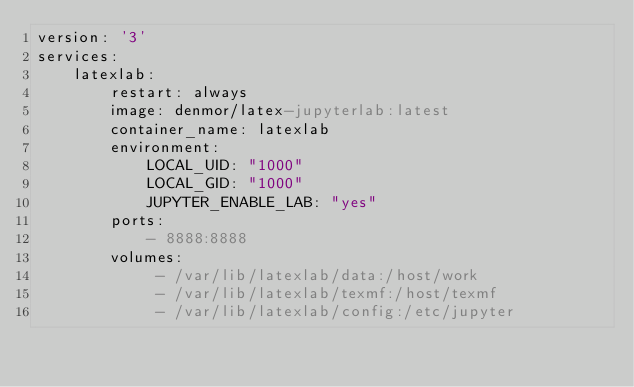<code> <loc_0><loc_0><loc_500><loc_500><_YAML_>version: '3'
services:
    latexlab:
        restart: always
        image: denmor/latex-jupyterlab:latest
        container_name: latexlab
        environment:
            LOCAL_UID: "1000"
            LOCAL_GID: "1000"
            JUPYTER_ENABLE_LAB: "yes"
        ports:
            - 8888:8888
        volumes:
             - /var/lib/latexlab/data:/host/work
             - /var/lib/latexlab/texmf:/host/texmf
             - /var/lib/latexlab/config:/etc/jupyter
</code> 